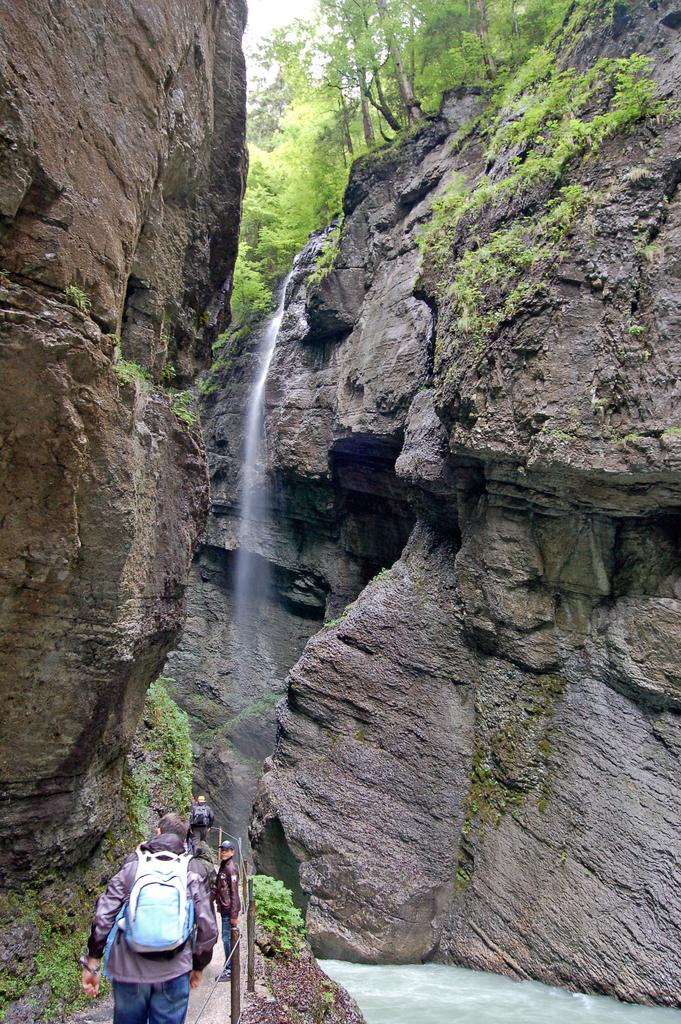What geographical feature is the main subject of the image? There is a mountain in the image. What type of vegetation can be seen in the image? There are trees in the image. What type of transportation infrastructure is present in the image? There is a road with railing in the image. What natural feature is present between the mountains in the image? There is a body of water between the mountains in the image. How many people are acting in a play in the image? There is no reference to a play or any people in the image; it features a mountain, trees, a road with railing, and a body of water. 